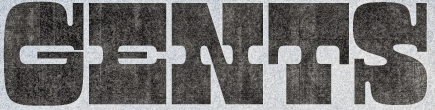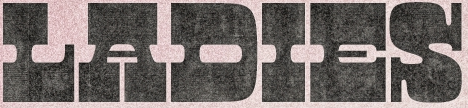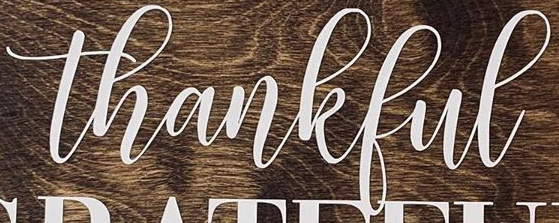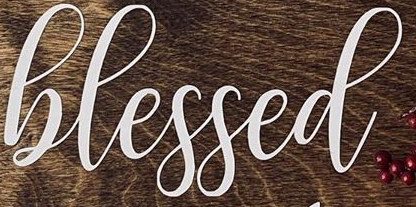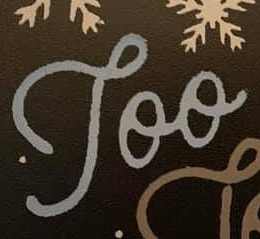Read the text from these images in sequence, separated by a semicolon. GENTS; LADIES; thankful; hlessed; Too 